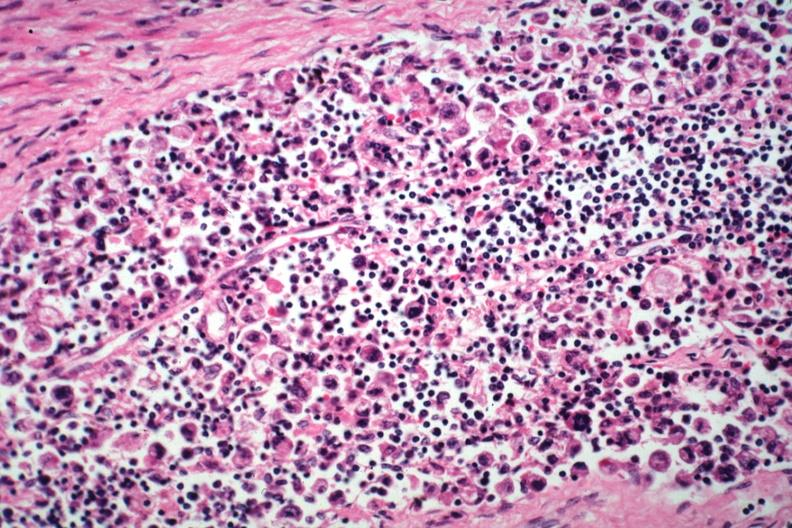how is incidental finding died?
Answer the question using a single word or phrase. Promyelocytic leukemia stomach lesion # 